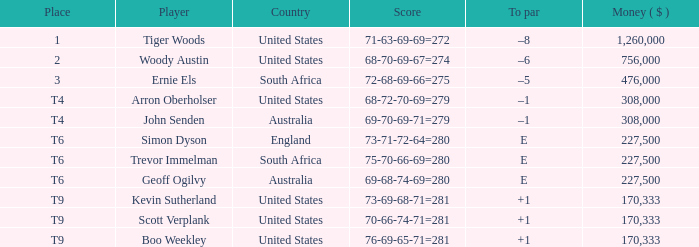What country does Tiger Woods play for? United States. I'm looking to parse the entire table for insights. Could you assist me with that? {'header': ['Place', 'Player', 'Country', 'Score', 'To par', 'Money ( $ )'], 'rows': [['1', 'Tiger Woods', 'United States', '71-63-69-69=272', '–8', '1,260,000'], ['2', 'Woody Austin', 'United States', '68-70-69-67=274', '–6', '756,000'], ['3', 'Ernie Els', 'South Africa', '72-68-69-66=275', '–5', '476,000'], ['T4', 'Arron Oberholser', 'United States', '68-72-70-69=279', '–1', '308,000'], ['T4', 'John Senden', 'Australia', '69-70-69-71=279', '–1', '308,000'], ['T6', 'Simon Dyson', 'England', '73-71-72-64=280', 'E', '227,500'], ['T6', 'Trevor Immelman', 'South Africa', '75-70-66-69=280', 'E', '227,500'], ['T6', 'Geoff Ogilvy', 'Australia', '69-68-74-69=280', 'E', '227,500'], ['T9', 'Kevin Sutherland', 'United States', '73-69-68-71=281', '+1', '170,333'], ['T9', 'Scott Verplank', 'United States', '70-66-74-71=281', '+1', '170,333'], ['T9', 'Boo Weekley', 'United States', '76-69-65-71=281', '+1', '170,333']]} 